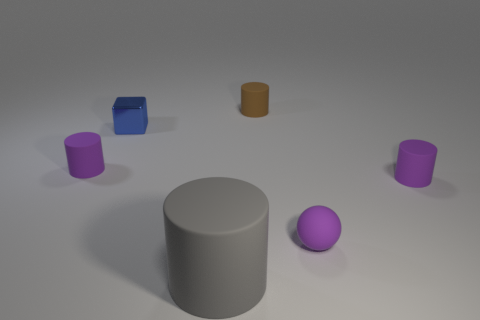Subtract all purple spheres. How many gray cylinders are left? 1 Subtract all big yellow matte things. Subtract all blue cubes. How many objects are left? 5 Add 1 gray matte cylinders. How many gray matte cylinders are left? 2 Add 4 tiny purple things. How many tiny purple things exist? 7 Add 1 blue cubes. How many objects exist? 7 Subtract all purple cylinders. How many cylinders are left? 2 Subtract all small cylinders. How many cylinders are left? 1 Subtract 0 green spheres. How many objects are left? 6 Subtract all cylinders. How many objects are left? 2 Subtract 1 cylinders. How many cylinders are left? 3 